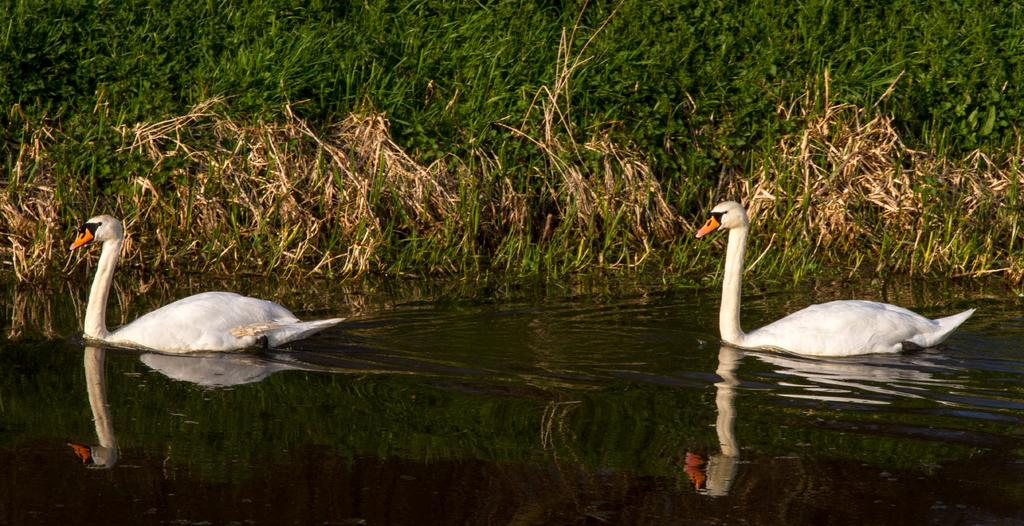What type of animals can be seen in the image? There are swans in the water. What can be seen in the background of the image? There is grass visible in the background of the image. What is the argument about between the swans in the image? There is no argument present in the image; it features swans in the water and grass in the background. 